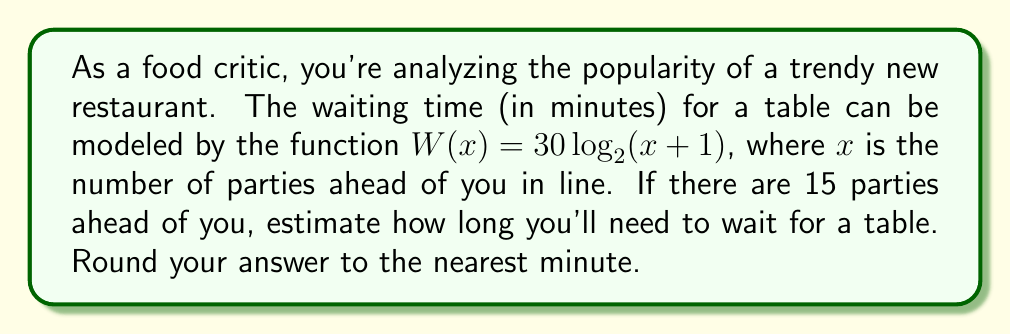Can you answer this question? Let's approach this step-by-step:

1) We're given the waiting time function: $W(x) = 30 \log_2(x + 1)$

2) We need to find $W(15)$ since there are 15 parties ahead:

   $W(15) = 30 \log_2(15 + 1)$

3) Simplify inside the parentheses:

   $W(15) = 30 \log_2(16)$

4) Now, we need to calculate $\log_2(16)$:
   
   $2^4 = 16$, so $\log_2(16) = 4$

5) Substitute this value:

   $W(15) = 30 \cdot 4 = 120$

6) Therefore, the estimated waiting time is 120 minutes.

7) The question asks to round to the nearest minute, but 120 is already a whole number, so no rounding is necessary.
Answer: 120 minutes 